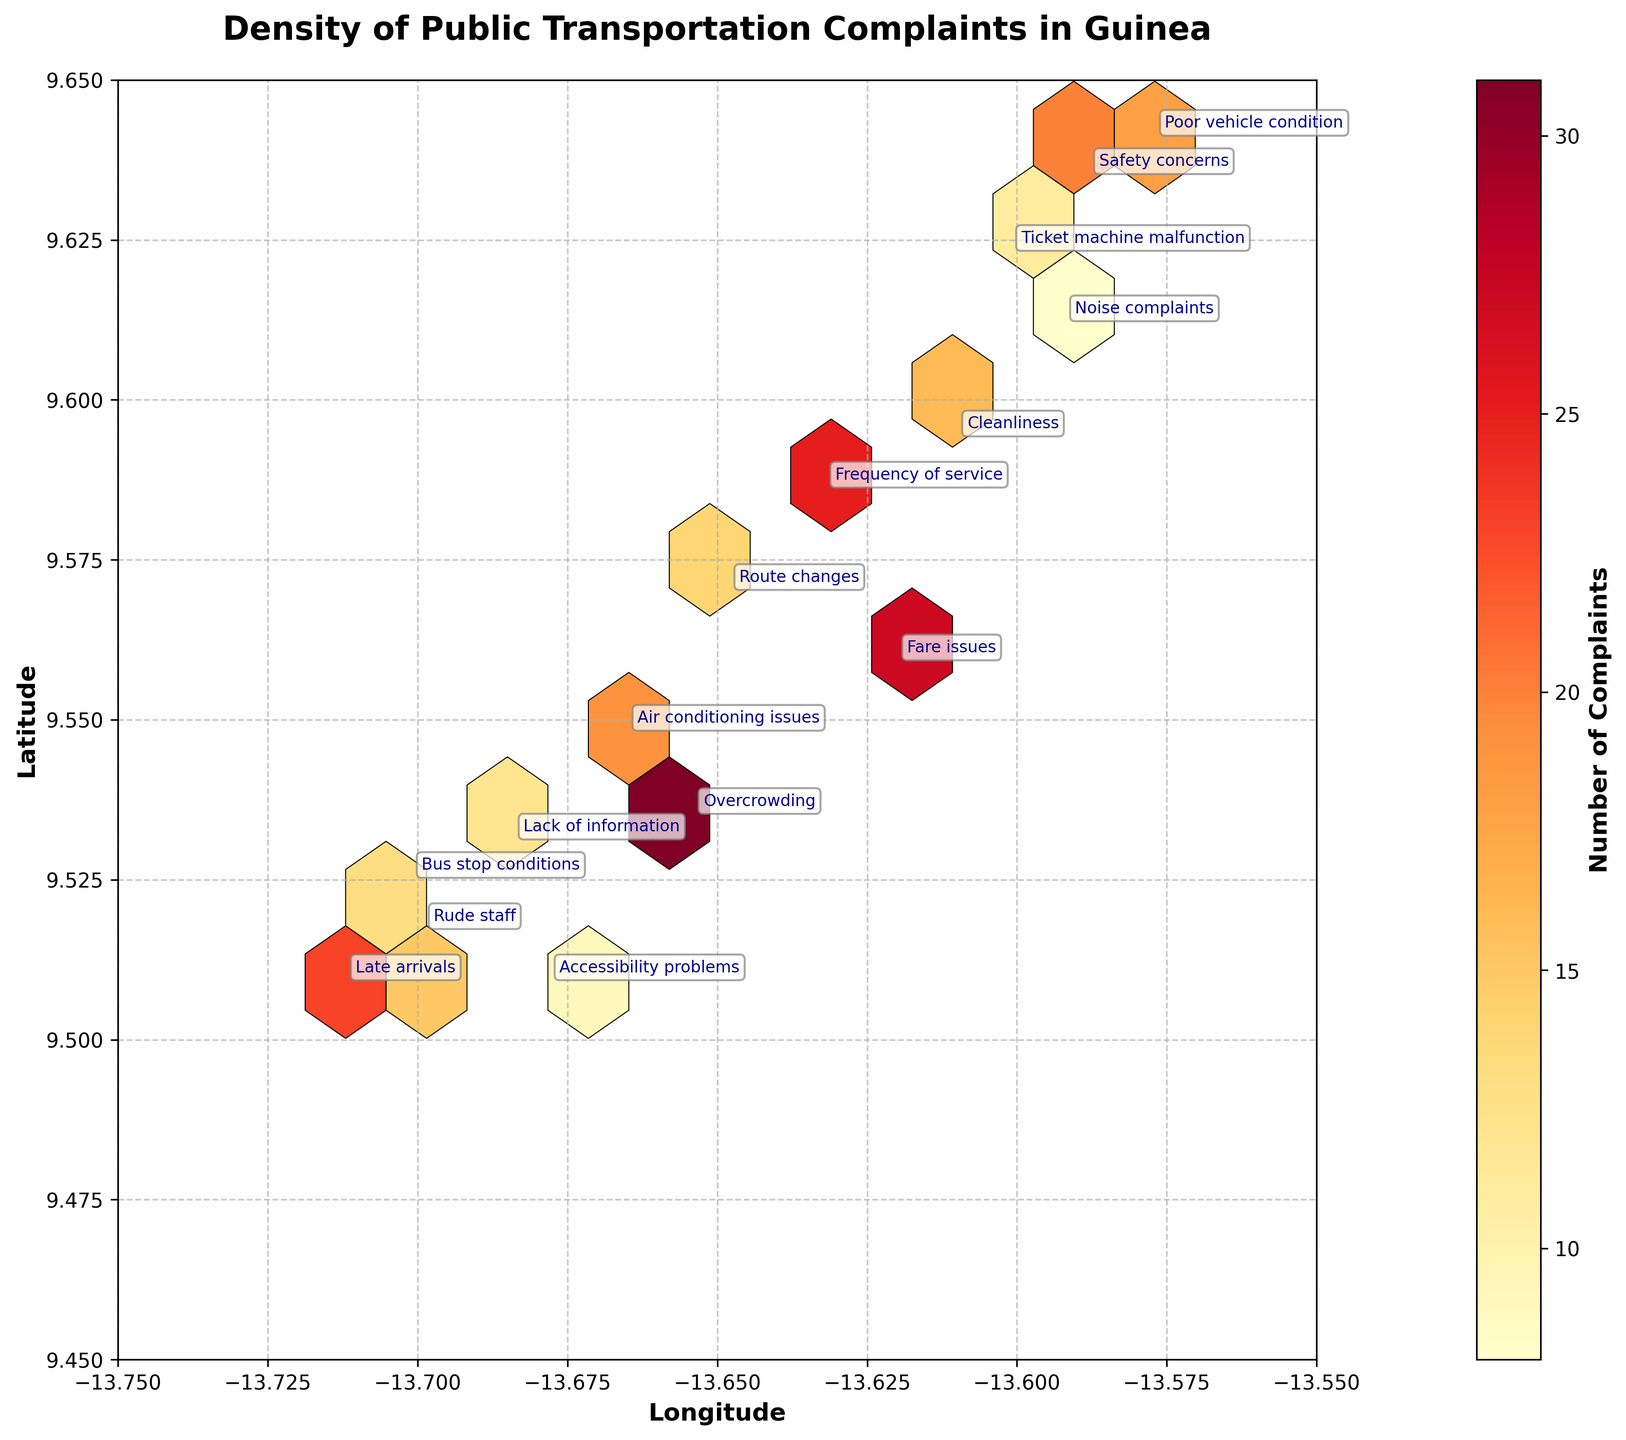What is the title of the figure? The title is prominently displayed at the top of the plot.
Answer: Density of Public Transportation Complaints in Guinea What does the color bar represent on the right side of the plot? The color bar indicates the number of complaints with different shades representing varying intensities.
Answer: Number of Complaints Which location has the highest density of complaints? Find the hexbin with the darkest shade, typically in the central part of the plot.
Answer: Near -13.654 longitude and 9.535 latitude What are the latitude and longitude ranges visible in the plot? Check the x-axis and y-axis limits.
Answer: Longitude: -13.75 to -13.55, Latitude: 9.45 to 9.65 Which type of complaint is located at approximately 9.509 latitude and -13.712 longitude? Look at the annotated text near these coordinates.
Answer: Late arrivals Are there more complaints about "Overcrowding" or "Fare issues"? Compare the complaint counts at the respective annotated coordinates.
Answer: Overcrowding Which complaint type is located at approximately 9.641 latitude and -13.577 longitude? Identify the label closest to these coordinates.
Answer: Poor vehicle condition Does the plot show more complaints in the northern or southern part of the mapped area? Compare the density of hexbin shades in the top versus the bottom half of the plot.
Answer: Northern part Is there any complaint located close to the -13.6 longitude and 9.612 latitude? If yes, what is it? Look for any annotations near these coordinates.
Answer: Noise complaints Which type of complaint has the lowest count, and where is it located? The label indicates 8 complaints, and it is near -13.592 longitude and 9.612 latitude.
Answer: Noise complaints 